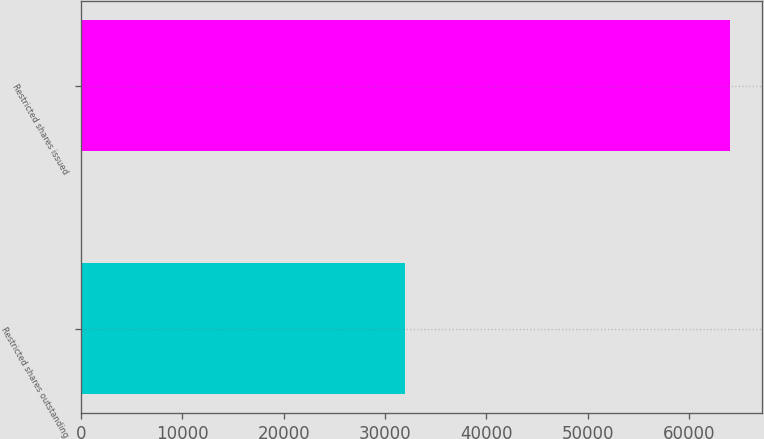Convert chart. <chart><loc_0><loc_0><loc_500><loc_500><bar_chart><fcel>Restricted shares outstanding<fcel>Restricted shares issued<nl><fcel>32000<fcel>64000<nl></chart> 